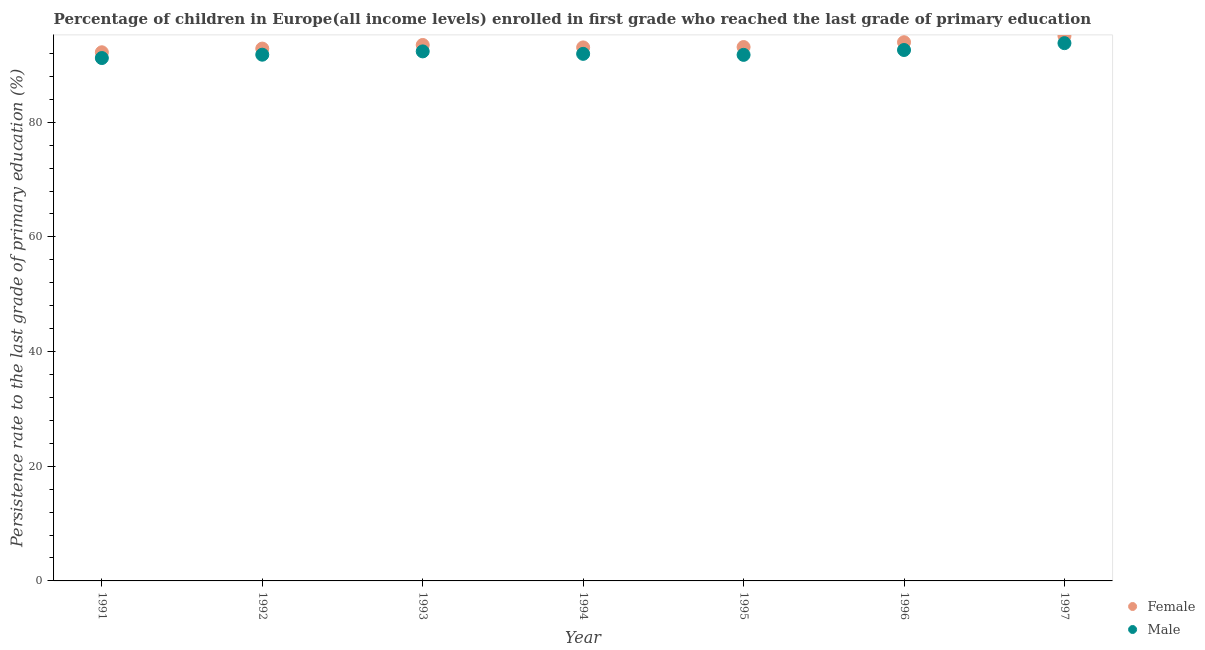What is the persistence rate of male students in 1991?
Offer a very short reply. 91.19. Across all years, what is the maximum persistence rate of female students?
Your response must be concise. 95.04. Across all years, what is the minimum persistence rate of female students?
Ensure brevity in your answer.  92.19. In which year was the persistence rate of male students maximum?
Make the answer very short. 1997. What is the total persistence rate of male students in the graph?
Your response must be concise. 645.35. What is the difference between the persistence rate of male students in 1991 and that in 1992?
Keep it short and to the point. -0.58. What is the difference between the persistence rate of female students in 1997 and the persistence rate of male students in 1996?
Your response must be concise. 2.45. What is the average persistence rate of male students per year?
Give a very brief answer. 92.19. In the year 1993, what is the difference between the persistence rate of male students and persistence rate of female students?
Provide a short and direct response. -1.12. What is the ratio of the persistence rate of male students in 1992 to that in 1996?
Ensure brevity in your answer.  0.99. Is the persistence rate of male students in 1994 less than that in 1996?
Provide a succinct answer. Yes. Is the difference between the persistence rate of male students in 1996 and 1997 greater than the difference between the persistence rate of female students in 1996 and 1997?
Your answer should be very brief. No. What is the difference between the highest and the second highest persistence rate of male students?
Your answer should be compact. 1.19. What is the difference between the highest and the lowest persistence rate of male students?
Your answer should be compact. 2.6. Is the sum of the persistence rate of male students in 1993 and 1995 greater than the maximum persistence rate of female students across all years?
Your response must be concise. Yes. Does the persistence rate of female students monotonically increase over the years?
Keep it short and to the point. No. How many dotlines are there?
Offer a terse response. 2. How many years are there in the graph?
Your answer should be very brief. 7. What is the difference between two consecutive major ticks on the Y-axis?
Keep it short and to the point. 20. Does the graph contain any zero values?
Offer a terse response. No. How are the legend labels stacked?
Provide a short and direct response. Vertical. What is the title of the graph?
Your answer should be compact. Percentage of children in Europe(all income levels) enrolled in first grade who reached the last grade of primary education. What is the label or title of the X-axis?
Your response must be concise. Year. What is the label or title of the Y-axis?
Your response must be concise. Persistence rate to the last grade of primary education (%). What is the Persistence rate to the last grade of primary education (%) of Female in 1991?
Make the answer very short. 92.19. What is the Persistence rate to the last grade of primary education (%) in Male in 1991?
Provide a succinct answer. 91.19. What is the Persistence rate to the last grade of primary education (%) of Female in 1992?
Your response must be concise. 92.84. What is the Persistence rate to the last grade of primary education (%) in Male in 1992?
Make the answer very short. 91.77. What is the Persistence rate to the last grade of primary education (%) of Female in 1993?
Provide a succinct answer. 93.47. What is the Persistence rate to the last grade of primary education (%) of Male in 1993?
Provide a short and direct response. 92.35. What is the Persistence rate to the last grade of primary education (%) in Female in 1994?
Ensure brevity in your answer.  93.04. What is the Persistence rate to the last grade of primary education (%) of Male in 1994?
Your response must be concise. 91.92. What is the Persistence rate to the last grade of primary education (%) in Female in 1995?
Offer a very short reply. 93.1. What is the Persistence rate to the last grade of primary education (%) of Male in 1995?
Offer a terse response. 91.74. What is the Persistence rate to the last grade of primary education (%) in Female in 1996?
Ensure brevity in your answer.  93.95. What is the Persistence rate to the last grade of primary education (%) of Male in 1996?
Offer a terse response. 92.59. What is the Persistence rate to the last grade of primary education (%) of Female in 1997?
Offer a terse response. 95.04. What is the Persistence rate to the last grade of primary education (%) in Male in 1997?
Your answer should be compact. 93.79. Across all years, what is the maximum Persistence rate to the last grade of primary education (%) in Female?
Provide a short and direct response. 95.04. Across all years, what is the maximum Persistence rate to the last grade of primary education (%) of Male?
Your response must be concise. 93.79. Across all years, what is the minimum Persistence rate to the last grade of primary education (%) of Female?
Keep it short and to the point. 92.19. Across all years, what is the minimum Persistence rate to the last grade of primary education (%) of Male?
Your answer should be very brief. 91.19. What is the total Persistence rate to the last grade of primary education (%) of Female in the graph?
Your answer should be compact. 653.63. What is the total Persistence rate to the last grade of primary education (%) of Male in the graph?
Offer a very short reply. 645.35. What is the difference between the Persistence rate to the last grade of primary education (%) in Female in 1991 and that in 1992?
Offer a very short reply. -0.64. What is the difference between the Persistence rate to the last grade of primary education (%) of Male in 1991 and that in 1992?
Provide a short and direct response. -0.58. What is the difference between the Persistence rate to the last grade of primary education (%) of Female in 1991 and that in 1993?
Offer a terse response. -1.27. What is the difference between the Persistence rate to the last grade of primary education (%) in Male in 1991 and that in 1993?
Provide a short and direct response. -1.16. What is the difference between the Persistence rate to the last grade of primary education (%) in Female in 1991 and that in 1994?
Offer a terse response. -0.85. What is the difference between the Persistence rate to the last grade of primary education (%) in Male in 1991 and that in 1994?
Your response must be concise. -0.73. What is the difference between the Persistence rate to the last grade of primary education (%) of Female in 1991 and that in 1995?
Make the answer very short. -0.91. What is the difference between the Persistence rate to the last grade of primary education (%) of Male in 1991 and that in 1995?
Ensure brevity in your answer.  -0.55. What is the difference between the Persistence rate to the last grade of primary education (%) in Female in 1991 and that in 1996?
Provide a succinct answer. -1.75. What is the difference between the Persistence rate to the last grade of primary education (%) in Male in 1991 and that in 1996?
Your answer should be very brief. -1.4. What is the difference between the Persistence rate to the last grade of primary education (%) in Female in 1991 and that in 1997?
Provide a short and direct response. -2.84. What is the difference between the Persistence rate to the last grade of primary education (%) in Male in 1991 and that in 1997?
Offer a very short reply. -2.6. What is the difference between the Persistence rate to the last grade of primary education (%) of Female in 1992 and that in 1993?
Keep it short and to the point. -0.63. What is the difference between the Persistence rate to the last grade of primary education (%) of Male in 1992 and that in 1993?
Provide a succinct answer. -0.57. What is the difference between the Persistence rate to the last grade of primary education (%) in Female in 1992 and that in 1994?
Your answer should be very brief. -0.2. What is the difference between the Persistence rate to the last grade of primary education (%) in Male in 1992 and that in 1994?
Offer a terse response. -0.15. What is the difference between the Persistence rate to the last grade of primary education (%) in Female in 1992 and that in 1995?
Give a very brief answer. -0.27. What is the difference between the Persistence rate to the last grade of primary education (%) of Male in 1992 and that in 1995?
Your response must be concise. 0.03. What is the difference between the Persistence rate to the last grade of primary education (%) in Female in 1992 and that in 1996?
Your answer should be compact. -1.11. What is the difference between the Persistence rate to the last grade of primary education (%) in Male in 1992 and that in 1996?
Ensure brevity in your answer.  -0.82. What is the difference between the Persistence rate to the last grade of primary education (%) in Female in 1992 and that in 1997?
Make the answer very short. -2.2. What is the difference between the Persistence rate to the last grade of primary education (%) of Male in 1992 and that in 1997?
Make the answer very short. -2.01. What is the difference between the Persistence rate to the last grade of primary education (%) of Female in 1993 and that in 1994?
Your response must be concise. 0.43. What is the difference between the Persistence rate to the last grade of primary education (%) in Male in 1993 and that in 1994?
Provide a succinct answer. 0.43. What is the difference between the Persistence rate to the last grade of primary education (%) of Female in 1993 and that in 1995?
Your response must be concise. 0.36. What is the difference between the Persistence rate to the last grade of primary education (%) in Male in 1993 and that in 1995?
Your answer should be very brief. 0.6. What is the difference between the Persistence rate to the last grade of primary education (%) in Female in 1993 and that in 1996?
Provide a succinct answer. -0.48. What is the difference between the Persistence rate to the last grade of primary education (%) of Male in 1993 and that in 1996?
Provide a succinct answer. -0.24. What is the difference between the Persistence rate to the last grade of primary education (%) in Female in 1993 and that in 1997?
Your answer should be very brief. -1.57. What is the difference between the Persistence rate to the last grade of primary education (%) of Male in 1993 and that in 1997?
Your response must be concise. -1.44. What is the difference between the Persistence rate to the last grade of primary education (%) of Female in 1994 and that in 1995?
Ensure brevity in your answer.  -0.06. What is the difference between the Persistence rate to the last grade of primary education (%) of Male in 1994 and that in 1995?
Give a very brief answer. 0.18. What is the difference between the Persistence rate to the last grade of primary education (%) in Female in 1994 and that in 1996?
Offer a terse response. -0.91. What is the difference between the Persistence rate to the last grade of primary education (%) in Male in 1994 and that in 1996?
Provide a short and direct response. -0.67. What is the difference between the Persistence rate to the last grade of primary education (%) in Female in 1994 and that in 1997?
Ensure brevity in your answer.  -2. What is the difference between the Persistence rate to the last grade of primary education (%) of Male in 1994 and that in 1997?
Your response must be concise. -1.87. What is the difference between the Persistence rate to the last grade of primary education (%) in Female in 1995 and that in 1996?
Your response must be concise. -0.84. What is the difference between the Persistence rate to the last grade of primary education (%) of Male in 1995 and that in 1996?
Your response must be concise. -0.85. What is the difference between the Persistence rate to the last grade of primary education (%) of Female in 1995 and that in 1997?
Offer a very short reply. -1.93. What is the difference between the Persistence rate to the last grade of primary education (%) in Male in 1995 and that in 1997?
Ensure brevity in your answer.  -2.04. What is the difference between the Persistence rate to the last grade of primary education (%) in Female in 1996 and that in 1997?
Offer a very short reply. -1.09. What is the difference between the Persistence rate to the last grade of primary education (%) of Male in 1996 and that in 1997?
Provide a short and direct response. -1.19. What is the difference between the Persistence rate to the last grade of primary education (%) of Female in 1991 and the Persistence rate to the last grade of primary education (%) of Male in 1992?
Your response must be concise. 0.42. What is the difference between the Persistence rate to the last grade of primary education (%) of Female in 1991 and the Persistence rate to the last grade of primary education (%) of Male in 1993?
Your response must be concise. -0.15. What is the difference between the Persistence rate to the last grade of primary education (%) of Female in 1991 and the Persistence rate to the last grade of primary education (%) of Male in 1994?
Offer a very short reply. 0.27. What is the difference between the Persistence rate to the last grade of primary education (%) of Female in 1991 and the Persistence rate to the last grade of primary education (%) of Male in 1995?
Provide a short and direct response. 0.45. What is the difference between the Persistence rate to the last grade of primary education (%) of Female in 1991 and the Persistence rate to the last grade of primary education (%) of Male in 1996?
Ensure brevity in your answer.  -0.4. What is the difference between the Persistence rate to the last grade of primary education (%) of Female in 1991 and the Persistence rate to the last grade of primary education (%) of Male in 1997?
Offer a very short reply. -1.59. What is the difference between the Persistence rate to the last grade of primary education (%) of Female in 1992 and the Persistence rate to the last grade of primary education (%) of Male in 1993?
Provide a short and direct response. 0.49. What is the difference between the Persistence rate to the last grade of primary education (%) in Female in 1992 and the Persistence rate to the last grade of primary education (%) in Male in 1994?
Your response must be concise. 0.92. What is the difference between the Persistence rate to the last grade of primary education (%) in Female in 1992 and the Persistence rate to the last grade of primary education (%) in Male in 1995?
Provide a short and direct response. 1.1. What is the difference between the Persistence rate to the last grade of primary education (%) of Female in 1992 and the Persistence rate to the last grade of primary education (%) of Male in 1996?
Make the answer very short. 0.25. What is the difference between the Persistence rate to the last grade of primary education (%) of Female in 1992 and the Persistence rate to the last grade of primary education (%) of Male in 1997?
Your answer should be very brief. -0.95. What is the difference between the Persistence rate to the last grade of primary education (%) of Female in 1993 and the Persistence rate to the last grade of primary education (%) of Male in 1994?
Ensure brevity in your answer.  1.55. What is the difference between the Persistence rate to the last grade of primary education (%) of Female in 1993 and the Persistence rate to the last grade of primary education (%) of Male in 1995?
Offer a terse response. 1.72. What is the difference between the Persistence rate to the last grade of primary education (%) in Female in 1993 and the Persistence rate to the last grade of primary education (%) in Male in 1996?
Make the answer very short. 0.88. What is the difference between the Persistence rate to the last grade of primary education (%) in Female in 1993 and the Persistence rate to the last grade of primary education (%) in Male in 1997?
Your answer should be compact. -0.32. What is the difference between the Persistence rate to the last grade of primary education (%) of Female in 1994 and the Persistence rate to the last grade of primary education (%) of Male in 1995?
Keep it short and to the point. 1.3. What is the difference between the Persistence rate to the last grade of primary education (%) of Female in 1994 and the Persistence rate to the last grade of primary education (%) of Male in 1996?
Provide a short and direct response. 0.45. What is the difference between the Persistence rate to the last grade of primary education (%) in Female in 1994 and the Persistence rate to the last grade of primary education (%) in Male in 1997?
Offer a very short reply. -0.75. What is the difference between the Persistence rate to the last grade of primary education (%) of Female in 1995 and the Persistence rate to the last grade of primary education (%) of Male in 1996?
Provide a succinct answer. 0.51. What is the difference between the Persistence rate to the last grade of primary education (%) of Female in 1995 and the Persistence rate to the last grade of primary education (%) of Male in 1997?
Your answer should be very brief. -0.68. What is the difference between the Persistence rate to the last grade of primary education (%) of Female in 1996 and the Persistence rate to the last grade of primary education (%) of Male in 1997?
Provide a succinct answer. 0.16. What is the average Persistence rate to the last grade of primary education (%) of Female per year?
Offer a terse response. 93.38. What is the average Persistence rate to the last grade of primary education (%) in Male per year?
Your response must be concise. 92.19. In the year 1992, what is the difference between the Persistence rate to the last grade of primary education (%) of Female and Persistence rate to the last grade of primary education (%) of Male?
Your answer should be compact. 1.07. In the year 1993, what is the difference between the Persistence rate to the last grade of primary education (%) in Female and Persistence rate to the last grade of primary education (%) in Male?
Your answer should be very brief. 1.12. In the year 1994, what is the difference between the Persistence rate to the last grade of primary education (%) of Female and Persistence rate to the last grade of primary education (%) of Male?
Your response must be concise. 1.12. In the year 1995, what is the difference between the Persistence rate to the last grade of primary education (%) of Female and Persistence rate to the last grade of primary education (%) of Male?
Offer a very short reply. 1.36. In the year 1996, what is the difference between the Persistence rate to the last grade of primary education (%) of Female and Persistence rate to the last grade of primary education (%) of Male?
Your answer should be very brief. 1.36. In the year 1997, what is the difference between the Persistence rate to the last grade of primary education (%) in Female and Persistence rate to the last grade of primary education (%) in Male?
Your answer should be compact. 1.25. What is the ratio of the Persistence rate to the last grade of primary education (%) of Male in 1991 to that in 1992?
Offer a terse response. 0.99. What is the ratio of the Persistence rate to the last grade of primary education (%) in Female in 1991 to that in 1993?
Your answer should be compact. 0.99. What is the ratio of the Persistence rate to the last grade of primary education (%) of Male in 1991 to that in 1993?
Keep it short and to the point. 0.99. What is the ratio of the Persistence rate to the last grade of primary education (%) in Female in 1991 to that in 1994?
Provide a short and direct response. 0.99. What is the ratio of the Persistence rate to the last grade of primary education (%) in Male in 1991 to that in 1994?
Keep it short and to the point. 0.99. What is the ratio of the Persistence rate to the last grade of primary education (%) of Female in 1991 to that in 1995?
Your answer should be compact. 0.99. What is the ratio of the Persistence rate to the last grade of primary education (%) in Male in 1991 to that in 1995?
Ensure brevity in your answer.  0.99. What is the ratio of the Persistence rate to the last grade of primary education (%) of Female in 1991 to that in 1996?
Your answer should be very brief. 0.98. What is the ratio of the Persistence rate to the last grade of primary education (%) of Male in 1991 to that in 1996?
Provide a short and direct response. 0.98. What is the ratio of the Persistence rate to the last grade of primary education (%) in Female in 1991 to that in 1997?
Give a very brief answer. 0.97. What is the ratio of the Persistence rate to the last grade of primary education (%) of Male in 1991 to that in 1997?
Your answer should be very brief. 0.97. What is the ratio of the Persistence rate to the last grade of primary education (%) of Female in 1992 to that in 1994?
Offer a very short reply. 1. What is the ratio of the Persistence rate to the last grade of primary education (%) of Female in 1992 to that in 1995?
Keep it short and to the point. 1. What is the ratio of the Persistence rate to the last grade of primary education (%) in Female in 1992 to that in 1996?
Provide a short and direct response. 0.99. What is the ratio of the Persistence rate to the last grade of primary education (%) of Female in 1992 to that in 1997?
Make the answer very short. 0.98. What is the ratio of the Persistence rate to the last grade of primary education (%) in Male in 1992 to that in 1997?
Your response must be concise. 0.98. What is the ratio of the Persistence rate to the last grade of primary education (%) in Female in 1993 to that in 1994?
Your response must be concise. 1. What is the ratio of the Persistence rate to the last grade of primary education (%) in Male in 1993 to that in 1995?
Give a very brief answer. 1.01. What is the ratio of the Persistence rate to the last grade of primary education (%) in Female in 1993 to that in 1996?
Your answer should be compact. 0.99. What is the ratio of the Persistence rate to the last grade of primary education (%) in Female in 1993 to that in 1997?
Offer a terse response. 0.98. What is the ratio of the Persistence rate to the last grade of primary education (%) of Male in 1993 to that in 1997?
Your answer should be compact. 0.98. What is the ratio of the Persistence rate to the last grade of primary education (%) of Female in 1994 to that in 1995?
Keep it short and to the point. 1. What is the ratio of the Persistence rate to the last grade of primary education (%) of Female in 1994 to that in 1996?
Your answer should be very brief. 0.99. What is the ratio of the Persistence rate to the last grade of primary education (%) of Female in 1994 to that in 1997?
Offer a very short reply. 0.98. What is the ratio of the Persistence rate to the last grade of primary education (%) in Male in 1994 to that in 1997?
Your response must be concise. 0.98. What is the ratio of the Persistence rate to the last grade of primary education (%) in Female in 1995 to that in 1997?
Keep it short and to the point. 0.98. What is the ratio of the Persistence rate to the last grade of primary education (%) in Male in 1995 to that in 1997?
Your answer should be very brief. 0.98. What is the ratio of the Persistence rate to the last grade of primary education (%) in Female in 1996 to that in 1997?
Your answer should be very brief. 0.99. What is the ratio of the Persistence rate to the last grade of primary education (%) in Male in 1996 to that in 1997?
Keep it short and to the point. 0.99. What is the difference between the highest and the second highest Persistence rate to the last grade of primary education (%) of Female?
Provide a succinct answer. 1.09. What is the difference between the highest and the second highest Persistence rate to the last grade of primary education (%) of Male?
Keep it short and to the point. 1.19. What is the difference between the highest and the lowest Persistence rate to the last grade of primary education (%) of Female?
Offer a terse response. 2.84. What is the difference between the highest and the lowest Persistence rate to the last grade of primary education (%) in Male?
Make the answer very short. 2.6. 